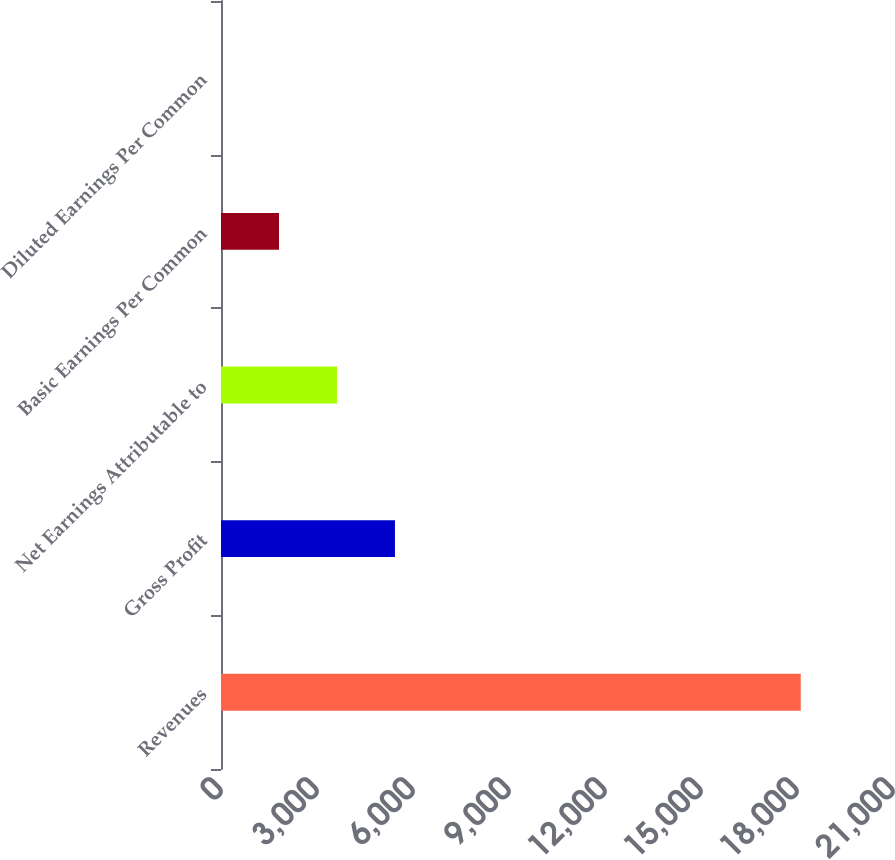<chart> <loc_0><loc_0><loc_500><loc_500><bar_chart><fcel>Revenues<fcel>Gross Profit<fcel>Net Earnings Attributable to<fcel>Basic Earnings Per Common<fcel>Diluted Earnings Per Common<nl><fcel>18117<fcel>5435.91<fcel>3624.32<fcel>1812.73<fcel>1.14<nl></chart> 